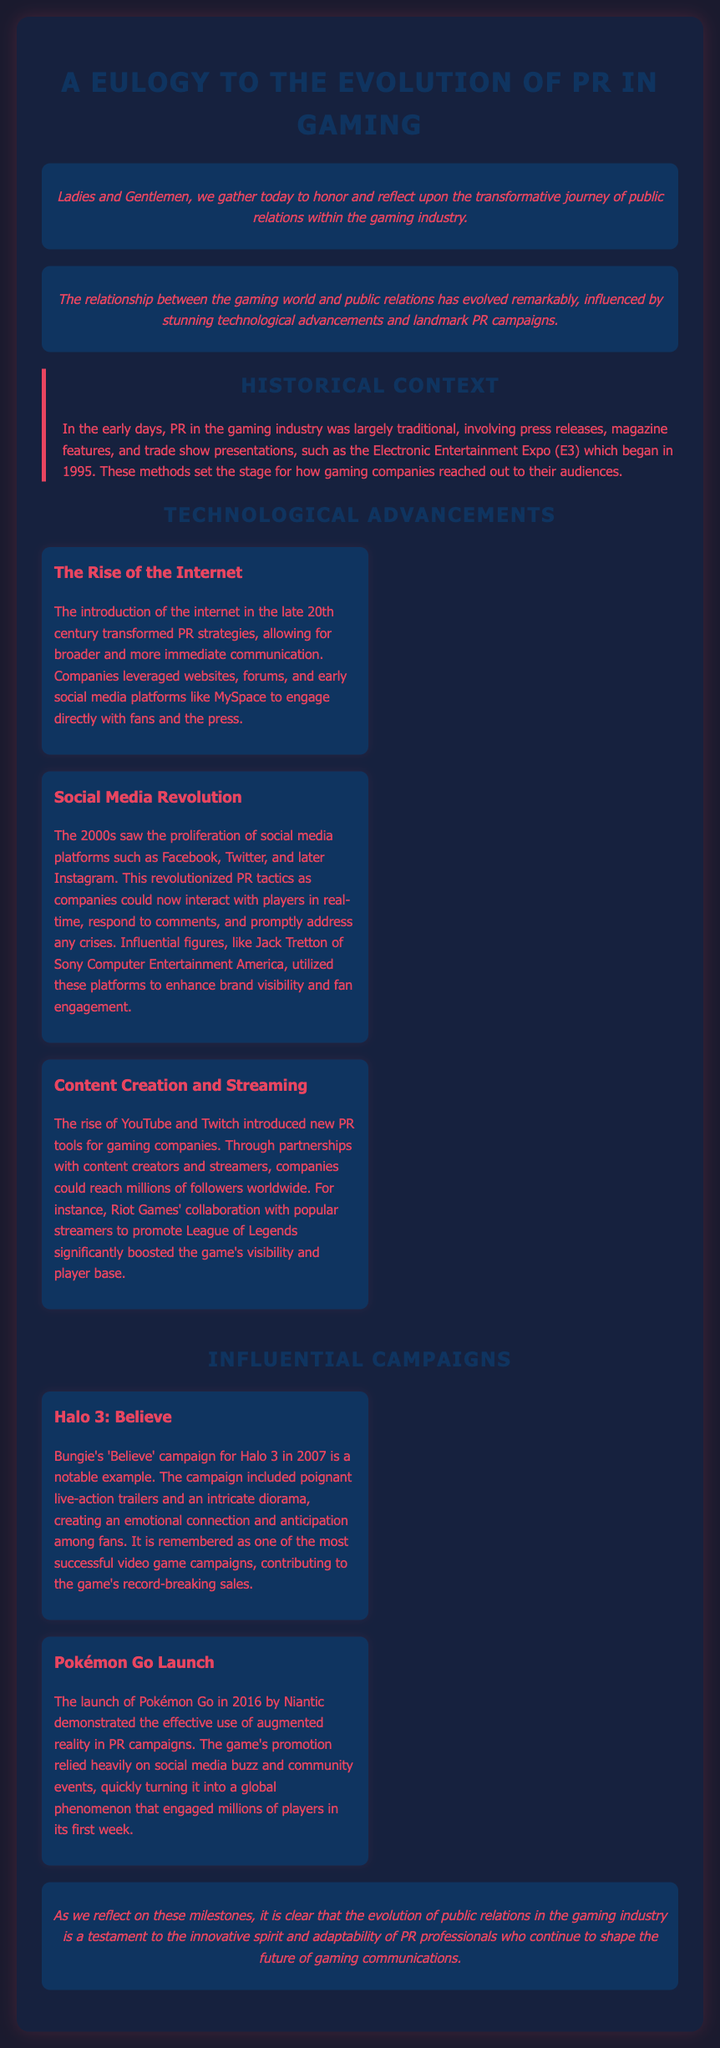What year did E3 begin? E3, which is the Electronic Entertainment Expo, began in 1995.
Answer: 1995 What significant advancement in PR occurred in the late 20th century? The introduction of the internet transformed PR strategies, allowing for broader and more immediate communication.
Answer: Internet Which gaming campaign is known for its live-action trailers? Bungie's 'Believe' campaign for Halo 3 in 2007 is remembered for its poignant live-action trailers.
Answer: Believe What year was Pokémon Go launched? Pokémon Go was launched in 2016 by Niantic.
Answer: 2016 Who was instrumental in enhancing brand visibility through social media? Jack Tretton of Sony Computer Entertainment America utilized social media to enhance brand visibility and fan engagement.
Answer: Jack Tretton How did Riot Games boost League of Legends' visibility? Riot Games collaborated with popular streamers to promote League of Legends, significantly boosting the game's visibility.
Answer: Collaborated with streamers What does the eulogy highlight about PR professionals in gaming? The eulogy states that the evolution of PR in gaming is a testament to the innovative spirit and adaptability of PR professionals.
Answer: Innovative spirit and adaptability Which two social media platforms revolutionized PR tactics in the 2000s? The 2000s saw the proliferation of social media platforms such as Facebook and Twitter.
Answer: Facebook and Twitter What aspect of Pokémon Go's launch demonstrated effective PR? The promotion of Pokémon Go relied heavily on social media buzz and community events.
Answer: Social media buzz and community events 